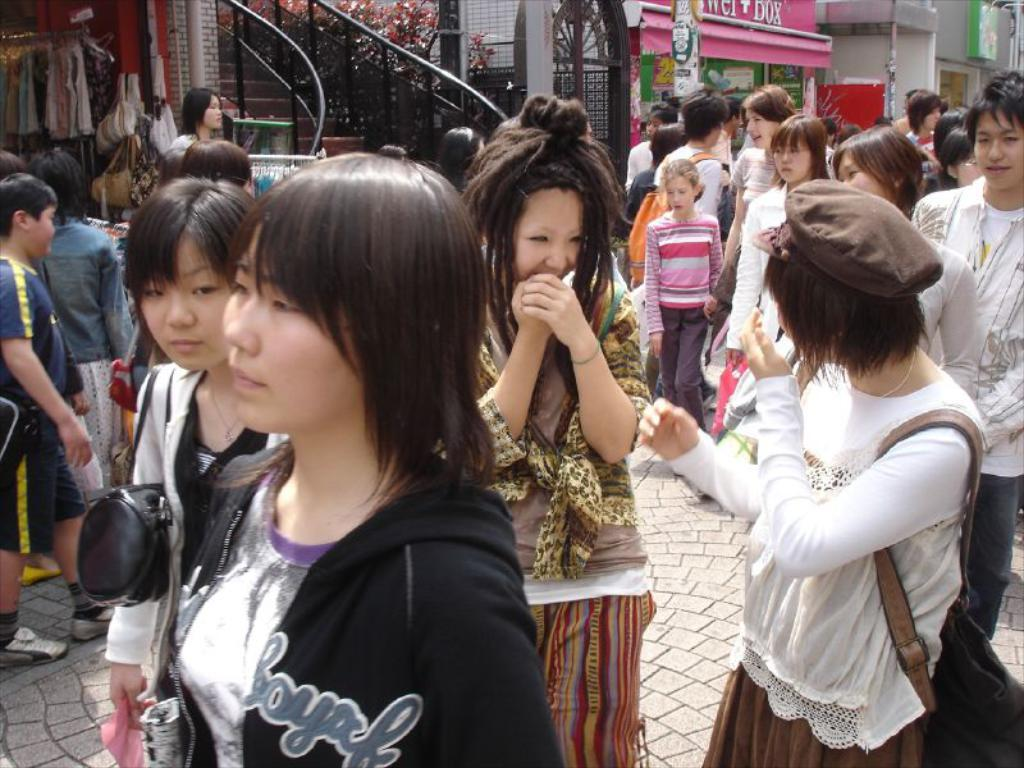What is the main feature in the center of the image? There are stairs in the center of the image. What can be seen happening in front of the image? People are walking on the road in front of the image. What is visible in the background of the image? There are buildings in the background of the image. What type of paste is being used to fix the buildings in the image? There is no indication in the image that any paste is being used to fix the buildings. 